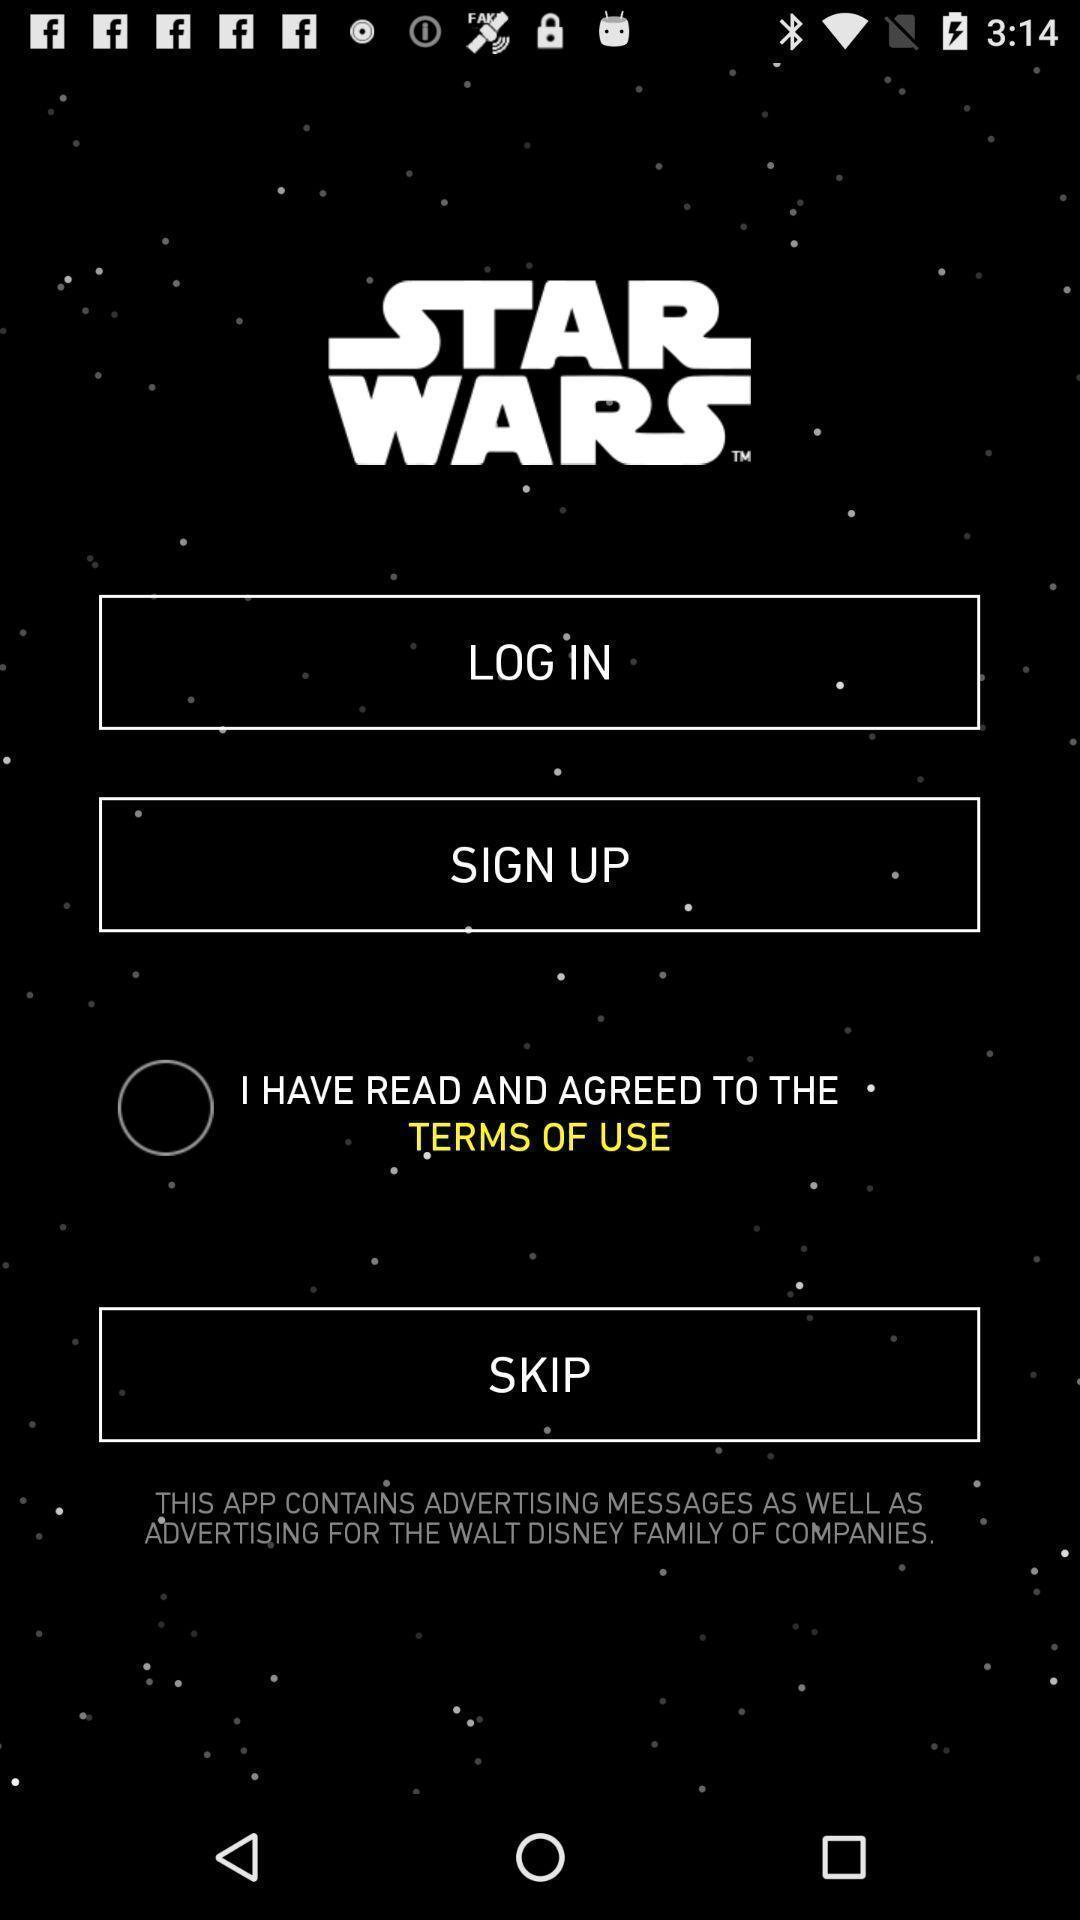Provide a detailed account of this screenshot. Login page. 